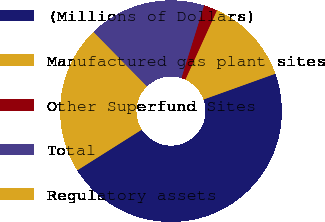<chart> <loc_0><loc_0><loc_500><loc_500><pie_chart><fcel>(Millions of Dollars)<fcel>Manufactured gas plant sites<fcel>Other Superfund Sites<fcel>Total<fcel>Regulatory assets<nl><fcel>46.53%<fcel>12.71%<fcel>1.98%<fcel>17.16%<fcel>21.62%<nl></chart> 